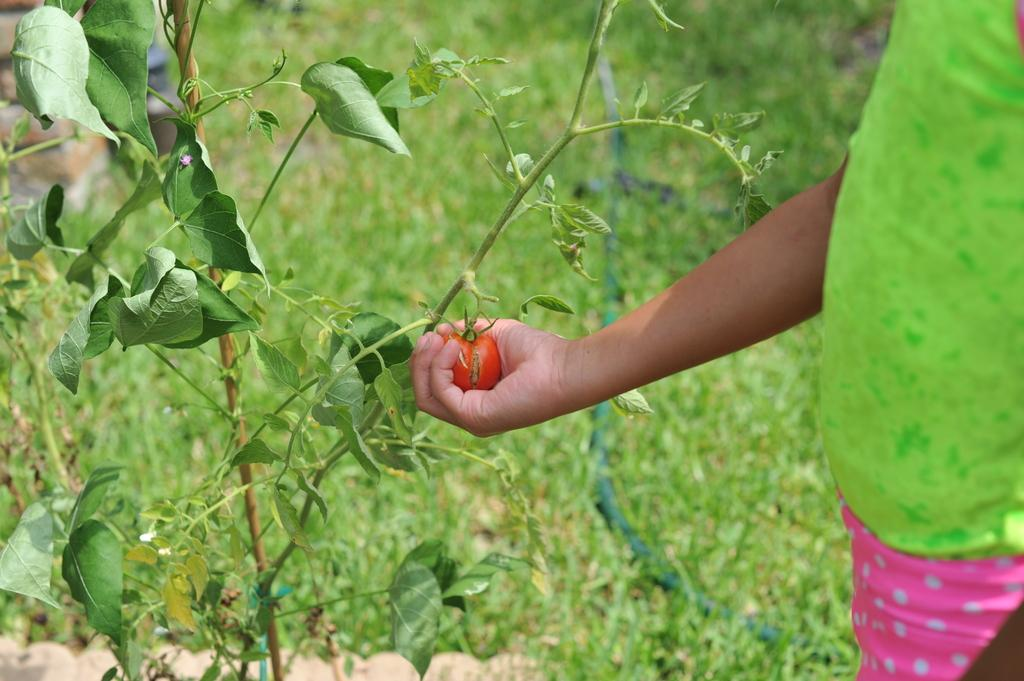Who is present in the image? There is a person in the image. What is the person holding in the image? The person is holding a tomato. Where is the tomato being held in relation to the plant? The tomato is being held near a plant. What can be seen in the background of the image? There is a pipeline, bricks, and plants in the background of the image. What is the distance between the person and their home in the image? There is no information about the person's home in the image, so we cannot determine the distance between them. What is the aftermath of the tomato harvest in the image? There is no indication of a tomato harvest in the image, so we cannot describe its aftermath. 